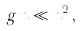Convert formula to latex. <formula><loc_0><loc_0><loc_500><loc_500>g \, n \ll n ^ { 2 } \, ,</formula> 